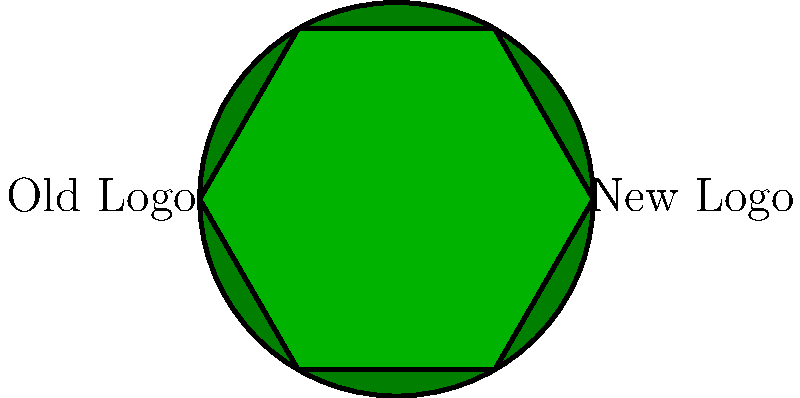Consider the simplified representations of Victoria Rosport's old and new team logos shown above. Which geometric transformation would be necessary to make the old logo congruent to the new logo? To determine the geometric transformation needed to make the old logo congruent to the new logo, let's analyze the shapes step-by-step:

1. The old logo is represented by a circle, while the new logo is represented by a regular hexagon.

2. For two shapes to be congruent, they must have the same shape and size, meaning all corresponding angles and sides must be equal.

3. A circle has infinite rotational symmetry and no vertices, while a regular hexagon has 6-fold rotational symmetry and 6 vertices.

4. No single geometric transformation (translation, rotation, reflection, or dilation) can transform a circle into a hexagon while preserving congruence.

5. Even if we consider multiple transformations, it is impossible to make a circle and a hexagon congruent because their fundamental shapes are different.

6. Congruence preserves shape and size, but these logos have different shapes (circle vs. hexagon).

Therefore, there is no geometric transformation or combination of transformations that can make the old logo congruent to the new logo. The shapes are fundamentally different and cannot be made congruent.
Answer: No transformation possible; shapes are not congruent. 